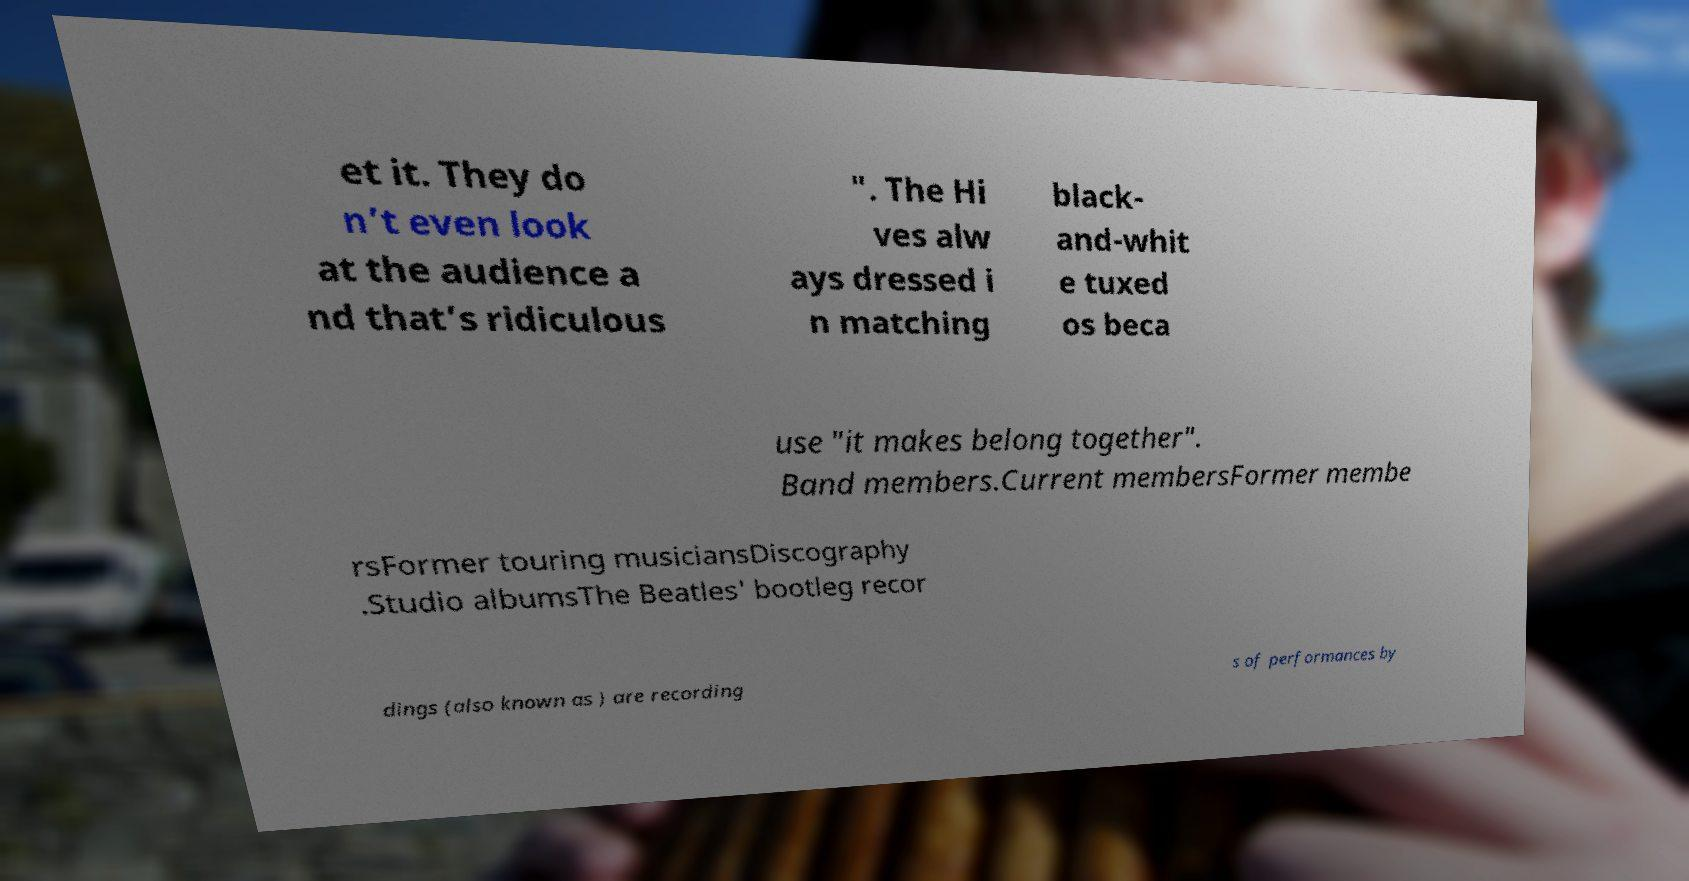There's text embedded in this image that I need extracted. Can you transcribe it verbatim? et it. They do n’t even look at the audience a nd that’s ridiculous ". The Hi ves alw ays dressed i n matching black- and-whit e tuxed os beca use "it makes belong together". Band members.Current membersFormer membe rsFormer touring musiciansDiscography .Studio albumsThe Beatles' bootleg recor dings (also known as ) are recording s of performances by 